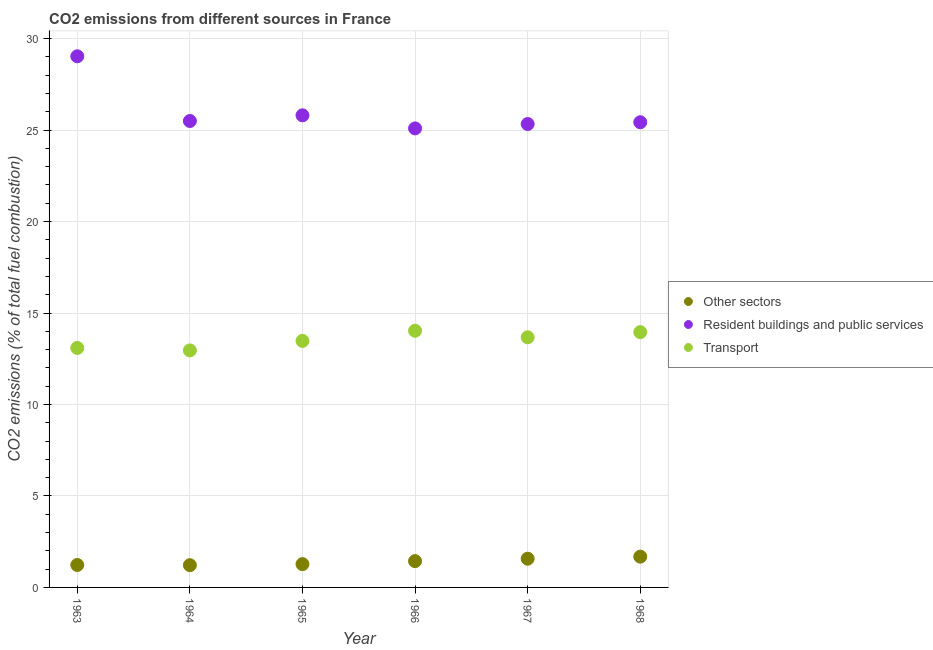How many different coloured dotlines are there?
Make the answer very short. 3. Is the number of dotlines equal to the number of legend labels?
Offer a very short reply. Yes. What is the percentage of co2 emissions from other sectors in 1968?
Your answer should be compact. 1.68. Across all years, what is the maximum percentage of co2 emissions from other sectors?
Offer a very short reply. 1.68. Across all years, what is the minimum percentage of co2 emissions from resident buildings and public services?
Offer a very short reply. 25.09. In which year was the percentage of co2 emissions from resident buildings and public services maximum?
Your answer should be very brief. 1963. In which year was the percentage of co2 emissions from transport minimum?
Your answer should be compact. 1964. What is the total percentage of co2 emissions from resident buildings and public services in the graph?
Ensure brevity in your answer.  156.19. What is the difference between the percentage of co2 emissions from resident buildings and public services in 1967 and that in 1968?
Your answer should be compact. -0.1. What is the difference between the percentage of co2 emissions from transport in 1966 and the percentage of co2 emissions from other sectors in 1965?
Your answer should be very brief. 12.76. What is the average percentage of co2 emissions from other sectors per year?
Keep it short and to the point. 1.4. In the year 1967, what is the difference between the percentage of co2 emissions from transport and percentage of co2 emissions from other sectors?
Your answer should be compact. 12.1. What is the ratio of the percentage of co2 emissions from other sectors in 1966 to that in 1968?
Your answer should be compact. 0.85. What is the difference between the highest and the second highest percentage of co2 emissions from transport?
Your response must be concise. 0.07. What is the difference between the highest and the lowest percentage of co2 emissions from resident buildings and public services?
Give a very brief answer. 3.94. In how many years, is the percentage of co2 emissions from other sectors greater than the average percentage of co2 emissions from other sectors taken over all years?
Ensure brevity in your answer.  3. Is it the case that in every year, the sum of the percentage of co2 emissions from other sectors and percentage of co2 emissions from resident buildings and public services is greater than the percentage of co2 emissions from transport?
Keep it short and to the point. Yes. Does the percentage of co2 emissions from other sectors monotonically increase over the years?
Your response must be concise. No. How many years are there in the graph?
Offer a very short reply. 6. What is the difference between two consecutive major ticks on the Y-axis?
Your response must be concise. 5. Are the values on the major ticks of Y-axis written in scientific E-notation?
Your answer should be compact. No. Does the graph contain any zero values?
Provide a succinct answer. No. Does the graph contain grids?
Make the answer very short. Yes. Where does the legend appear in the graph?
Ensure brevity in your answer.  Center right. How many legend labels are there?
Your response must be concise. 3. How are the legend labels stacked?
Ensure brevity in your answer.  Vertical. What is the title of the graph?
Offer a very short reply. CO2 emissions from different sources in France. What is the label or title of the Y-axis?
Your answer should be compact. CO2 emissions (% of total fuel combustion). What is the CO2 emissions (% of total fuel combustion) in Other sectors in 1963?
Your response must be concise. 1.23. What is the CO2 emissions (% of total fuel combustion) of Resident buildings and public services in 1963?
Provide a short and direct response. 29.04. What is the CO2 emissions (% of total fuel combustion) of Transport in 1963?
Your answer should be compact. 13.09. What is the CO2 emissions (% of total fuel combustion) of Other sectors in 1964?
Offer a very short reply. 1.22. What is the CO2 emissions (% of total fuel combustion) of Resident buildings and public services in 1964?
Make the answer very short. 25.5. What is the CO2 emissions (% of total fuel combustion) of Transport in 1964?
Your answer should be compact. 12.96. What is the CO2 emissions (% of total fuel combustion) of Other sectors in 1965?
Make the answer very short. 1.27. What is the CO2 emissions (% of total fuel combustion) of Resident buildings and public services in 1965?
Make the answer very short. 25.81. What is the CO2 emissions (% of total fuel combustion) in Transport in 1965?
Offer a terse response. 13.48. What is the CO2 emissions (% of total fuel combustion) in Other sectors in 1966?
Your response must be concise. 1.44. What is the CO2 emissions (% of total fuel combustion) in Resident buildings and public services in 1966?
Give a very brief answer. 25.09. What is the CO2 emissions (% of total fuel combustion) in Transport in 1966?
Offer a very short reply. 14.03. What is the CO2 emissions (% of total fuel combustion) in Other sectors in 1967?
Keep it short and to the point. 1.57. What is the CO2 emissions (% of total fuel combustion) of Resident buildings and public services in 1967?
Give a very brief answer. 25.33. What is the CO2 emissions (% of total fuel combustion) of Transport in 1967?
Provide a short and direct response. 13.67. What is the CO2 emissions (% of total fuel combustion) of Other sectors in 1968?
Your answer should be very brief. 1.68. What is the CO2 emissions (% of total fuel combustion) of Resident buildings and public services in 1968?
Offer a very short reply. 25.43. What is the CO2 emissions (% of total fuel combustion) of Transport in 1968?
Provide a short and direct response. 13.96. Across all years, what is the maximum CO2 emissions (% of total fuel combustion) in Other sectors?
Keep it short and to the point. 1.68. Across all years, what is the maximum CO2 emissions (% of total fuel combustion) in Resident buildings and public services?
Ensure brevity in your answer.  29.04. Across all years, what is the maximum CO2 emissions (% of total fuel combustion) of Transport?
Your answer should be compact. 14.03. Across all years, what is the minimum CO2 emissions (% of total fuel combustion) of Other sectors?
Your answer should be compact. 1.22. Across all years, what is the minimum CO2 emissions (% of total fuel combustion) of Resident buildings and public services?
Offer a very short reply. 25.09. Across all years, what is the minimum CO2 emissions (% of total fuel combustion) of Transport?
Ensure brevity in your answer.  12.96. What is the total CO2 emissions (% of total fuel combustion) of Other sectors in the graph?
Give a very brief answer. 8.41. What is the total CO2 emissions (% of total fuel combustion) of Resident buildings and public services in the graph?
Your answer should be compact. 156.19. What is the total CO2 emissions (% of total fuel combustion) in Transport in the graph?
Give a very brief answer. 81.18. What is the difference between the CO2 emissions (% of total fuel combustion) in Other sectors in 1963 and that in 1964?
Offer a very short reply. 0.01. What is the difference between the CO2 emissions (% of total fuel combustion) of Resident buildings and public services in 1963 and that in 1964?
Your response must be concise. 3.54. What is the difference between the CO2 emissions (% of total fuel combustion) of Transport in 1963 and that in 1964?
Offer a terse response. 0.14. What is the difference between the CO2 emissions (% of total fuel combustion) in Other sectors in 1963 and that in 1965?
Offer a very short reply. -0.05. What is the difference between the CO2 emissions (% of total fuel combustion) in Resident buildings and public services in 1963 and that in 1965?
Offer a very short reply. 3.23. What is the difference between the CO2 emissions (% of total fuel combustion) in Transport in 1963 and that in 1965?
Make the answer very short. -0.39. What is the difference between the CO2 emissions (% of total fuel combustion) of Other sectors in 1963 and that in 1966?
Make the answer very short. -0.21. What is the difference between the CO2 emissions (% of total fuel combustion) in Resident buildings and public services in 1963 and that in 1966?
Provide a succinct answer. 3.94. What is the difference between the CO2 emissions (% of total fuel combustion) of Transport in 1963 and that in 1966?
Your answer should be compact. -0.94. What is the difference between the CO2 emissions (% of total fuel combustion) of Other sectors in 1963 and that in 1967?
Ensure brevity in your answer.  -0.34. What is the difference between the CO2 emissions (% of total fuel combustion) of Resident buildings and public services in 1963 and that in 1967?
Give a very brief answer. 3.7. What is the difference between the CO2 emissions (% of total fuel combustion) in Transport in 1963 and that in 1967?
Keep it short and to the point. -0.58. What is the difference between the CO2 emissions (% of total fuel combustion) of Other sectors in 1963 and that in 1968?
Your answer should be very brief. -0.46. What is the difference between the CO2 emissions (% of total fuel combustion) in Resident buildings and public services in 1963 and that in 1968?
Give a very brief answer. 3.61. What is the difference between the CO2 emissions (% of total fuel combustion) of Transport in 1963 and that in 1968?
Your answer should be very brief. -0.87. What is the difference between the CO2 emissions (% of total fuel combustion) of Other sectors in 1964 and that in 1965?
Your answer should be very brief. -0.06. What is the difference between the CO2 emissions (% of total fuel combustion) of Resident buildings and public services in 1964 and that in 1965?
Your response must be concise. -0.31. What is the difference between the CO2 emissions (% of total fuel combustion) of Transport in 1964 and that in 1965?
Make the answer very short. -0.52. What is the difference between the CO2 emissions (% of total fuel combustion) in Other sectors in 1964 and that in 1966?
Offer a very short reply. -0.22. What is the difference between the CO2 emissions (% of total fuel combustion) in Resident buildings and public services in 1964 and that in 1966?
Ensure brevity in your answer.  0.4. What is the difference between the CO2 emissions (% of total fuel combustion) of Transport in 1964 and that in 1966?
Provide a succinct answer. -1.07. What is the difference between the CO2 emissions (% of total fuel combustion) in Other sectors in 1964 and that in 1967?
Give a very brief answer. -0.35. What is the difference between the CO2 emissions (% of total fuel combustion) of Resident buildings and public services in 1964 and that in 1967?
Provide a short and direct response. 0.17. What is the difference between the CO2 emissions (% of total fuel combustion) in Transport in 1964 and that in 1967?
Provide a succinct answer. -0.72. What is the difference between the CO2 emissions (% of total fuel combustion) in Other sectors in 1964 and that in 1968?
Give a very brief answer. -0.47. What is the difference between the CO2 emissions (% of total fuel combustion) of Resident buildings and public services in 1964 and that in 1968?
Provide a short and direct response. 0.07. What is the difference between the CO2 emissions (% of total fuel combustion) in Transport in 1964 and that in 1968?
Offer a very short reply. -1. What is the difference between the CO2 emissions (% of total fuel combustion) in Other sectors in 1965 and that in 1966?
Offer a terse response. -0.16. What is the difference between the CO2 emissions (% of total fuel combustion) in Resident buildings and public services in 1965 and that in 1966?
Ensure brevity in your answer.  0.71. What is the difference between the CO2 emissions (% of total fuel combustion) in Transport in 1965 and that in 1966?
Your answer should be very brief. -0.55. What is the difference between the CO2 emissions (% of total fuel combustion) in Other sectors in 1965 and that in 1967?
Make the answer very short. -0.3. What is the difference between the CO2 emissions (% of total fuel combustion) in Resident buildings and public services in 1965 and that in 1967?
Provide a short and direct response. 0.48. What is the difference between the CO2 emissions (% of total fuel combustion) of Transport in 1965 and that in 1967?
Offer a terse response. -0.2. What is the difference between the CO2 emissions (% of total fuel combustion) of Other sectors in 1965 and that in 1968?
Provide a short and direct response. -0.41. What is the difference between the CO2 emissions (% of total fuel combustion) of Resident buildings and public services in 1965 and that in 1968?
Offer a very short reply. 0.38. What is the difference between the CO2 emissions (% of total fuel combustion) of Transport in 1965 and that in 1968?
Offer a very short reply. -0.48. What is the difference between the CO2 emissions (% of total fuel combustion) of Other sectors in 1966 and that in 1967?
Your response must be concise. -0.13. What is the difference between the CO2 emissions (% of total fuel combustion) in Resident buildings and public services in 1966 and that in 1967?
Keep it short and to the point. -0.24. What is the difference between the CO2 emissions (% of total fuel combustion) of Transport in 1966 and that in 1967?
Your response must be concise. 0.36. What is the difference between the CO2 emissions (% of total fuel combustion) of Other sectors in 1966 and that in 1968?
Give a very brief answer. -0.24. What is the difference between the CO2 emissions (% of total fuel combustion) in Resident buildings and public services in 1966 and that in 1968?
Offer a very short reply. -0.34. What is the difference between the CO2 emissions (% of total fuel combustion) of Transport in 1966 and that in 1968?
Make the answer very short. 0.07. What is the difference between the CO2 emissions (% of total fuel combustion) of Other sectors in 1967 and that in 1968?
Keep it short and to the point. -0.11. What is the difference between the CO2 emissions (% of total fuel combustion) of Resident buildings and public services in 1967 and that in 1968?
Offer a terse response. -0.1. What is the difference between the CO2 emissions (% of total fuel combustion) of Transport in 1967 and that in 1968?
Provide a short and direct response. -0.28. What is the difference between the CO2 emissions (% of total fuel combustion) of Other sectors in 1963 and the CO2 emissions (% of total fuel combustion) of Resident buildings and public services in 1964?
Keep it short and to the point. -24.27. What is the difference between the CO2 emissions (% of total fuel combustion) of Other sectors in 1963 and the CO2 emissions (% of total fuel combustion) of Transport in 1964?
Make the answer very short. -11.73. What is the difference between the CO2 emissions (% of total fuel combustion) of Resident buildings and public services in 1963 and the CO2 emissions (% of total fuel combustion) of Transport in 1964?
Offer a very short reply. 16.08. What is the difference between the CO2 emissions (% of total fuel combustion) of Other sectors in 1963 and the CO2 emissions (% of total fuel combustion) of Resident buildings and public services in 1965?
Offer a terse response. -24.58. What is the difference between the CO2 emissions (% of total fuel combustion) of Other sectors in 1963 and the CO2 emissions (% of total fuel combustion) of Transport in 1965?
Your answer should be very brief. -12.25. What is the difference between the CO2 emissions (% of total fuel combustion) of Resident buildings and public services in 1963 and the CO2 emissions (% of total fuel combustion) of Transport in 1965?
Offer a very short reply. 15.56. What is the difference between the CO2 emissions (% of total fuel combustion) of Other sectors in 1963 and the CO2 emissions (% of total fuel combustion) of Resident buildings and public services in 1966?
Offer a terse response. -23.87. What is the difference between the CO2 emissions (% of total fuel combustion) of Other sectors in 1963 and the CO2 emissions (% of total fuel combustion) of Transport in 1966?
Offer a terse response. -12.8. What is the difference between the CO2 emissions (% of total fuel combustion) in Resident buildings and public services in 1963 and the CO2 emissions (% of total fuel combustion) in Transport in 1966?
Your response must be concise. 15. What is the difference between the CO2 emissions (% of total fuel combustion) of Other sectors in 1963 and the CO2 emissions (% of total fuel combustion) of Resident buildings and public services in 1967?
Provide a succinct answer. -24.1. What is the difference between the CO2 emissions (% of total fuel combustion) in Other sectors in 1963 and the CO2 emissions (% of total fuel combustion) in Transport in 1967?
Your response must be concise. -12.45. What is the difference between the CO2 emissions (% of total fuel combustion) in Resident buildings and public services in 1963 and the CO2 emissions (% of total fuel combustion) in Transport in 1967?
Make the answer very short. 15.36. What is the difference between the CO2 emissions (% of total fuel combustion) of Other sectors in 1963 and the CO2 emissions (% of total fuel combustion) of Resident buildings and public services in 1968?
Provide a succinct answer. -24.2. What is the difference between the CO2 emissions (% of total fuel combustion) of Other sectors in 1963 and the CO2 emissions (% of total fuel combustion) of Transport in 1968?
Provide a short and direct response. -12.73. What is the difference between the CO2 emissions (% of total fuel combustion) in Resident buildings and public services in 1963 and the CO2 emissions (% of total fuel combustion) in Transport in 1968?
Offer a terse response. 15.08. What is the difference between the CO2 emissions (% of total fuel combustion) of Other sectors in 1964 and the CO2 emissions (% of total fuel combustion) of Resident buildings and public services in 1965?
Your answer should be very brief. -24.59. What is the difference between the CO2 emissions (% of total fuel combustion) of Other sectors in 1964 and the CO2 emissions (% of total fuel combustion) of Transport in 1965?
Keep it short and to the point. -12.26. What is the difference between the CO2 emissions (% of total fuel combustion) in Resident buildings and public services in 1964 and the CO2 emissions (% of total fuel combustion) in Transport in 1965?
Keep it short and to the point. 12.02. What is the difference between the CO2 emissions (% of total fuel combustion) in Other sectors in 1964 and the CO2 emissions (% of total fuel combustion) in Resident buildings and public services in 1966?
Offer a terse response. -23.88. What is the difference between the CO2 emissions (% of total fuel combustion) in Other sectors in 1964 and the CO2 emissions (% of total fuel combustion) in Transport in 1966?
Your answer should be very brief. -12.82. What is the difference between the CO2 emissions (% of total fuel combustion) of Resident buildings and public services in 1964 and the CO2 emissions (% of total fuel combustion) of Transport in 1966?
Keep it short and to the point. 11.47. What is the difference between the CO2 emissions (% of total fuel combustion) in Other sectors in 1964 and the CO2 emissions (% of total fuel combustion) in Resident buildings and public services in 1967?
Keep it short and to the point. -24.12. What is the difference between the CO2 emissions (% of total fuel combustion) of Other sectors in 1964 and the CO2 emissions (% of total fuel combustion) of Transport in 1967?
Provide a short and direct response. -12.46. What is the difference between the CO2 emissions (% of total fuel combustion) of Resident buildings and public services in 1964 and the CO2 emissions (% of total fuel combustion) of Transport in 1967?
Ensure brevity in your answer.  11.82. What is the difference between the CO2 emissions (% of total fuel combustion) in Other sectors in 1964 and the CO2 emissions (% of total fuel combustion) in Resident buildings and public services in 1968?
Your answer should be very brief. -24.21. What is the difference between the CO2 emissions (% of total fuel combustion) of Other sectors in 1964 and the CO2 emissions (% of total fuel combustion) of Transport in 1968?
Your answer should be compact. -12.74. What is the difference between the CO2 emissions (% of total fuel combustion) in Resident buildings and public services in 1964 and the CO2 emissions (% of total fuel combustion) in Transport in 1968?
Keep it short and to the point. 11.54. What is the difference between the CO2 emissions (% of total fuel combustion) in Other sectors in 1965 and the CO2 emissions (% of total fuel combustion) in Resident buildings and public services in 1966?
Provide a succinct answer. -23.82. What is the difference between the CO2 emissions (% of total fuel combustion) in Other sectors in 1965 and the CO2 emissions (% of total fuel combustion) in Transport in 1966?
Offer a terse response. -12.76. What is the difference between the CO2 emissions (% of total fuel combustion) of Resident buildings and public services in 1965 and the CO2 emissions (% of total fuel combustion) of Transport in 1966?
Offer a very short reply. 11.78. What is the difference between the CO2 emissions (% of total fuel combustion) of Other sectors in 1965 and the CO2 emissions (% of total fuel combustion) of Resident buildings and public services in 1967?
Ensure brevity in your answer.  -24.06. What is the difference between the CO2 emissions (% of total fuel combustion) in Other sectors in 1965 and the CO2 emissions (% of total fuel combustion) in Transport in 1967?
Your answer should be very brief. -12.4. What is the difference between the CO2 emissions (% of total fuel combustion) in Resident buildings and public services in 1965 and the CO2 emissions (% of total fuel combustion) in Transport in 1967?
Provide a succinct answer. 12.14. What is the difference between the CO2 emissions (% of total fuel combustion) in Other sectors in 1965 and the CO2 emissions (% of total fuel combustion) in Resident buildings and public services in 1968?
Ensure brevity in your answer.  -24.15. What is the difference between the CO2 emissions (% of total fuel combustion) of Other sectors in 1965 and the CO2 emissions (% of total fuel combustion) of Transport in 1968?
Offer a terse response. -12.68. What is the difference between the CO2 emissions (% of total fuel combustion) of Resident buildings and public services in 1965 and the CO2 emissions (% of total fuel combustion) of Transport in 1968?
Provide a succinct answer. 11.85. What is the difference between the CO2 emissions (% of total fuel combustion) in Other sectors in 1966 and the CO2 emissions (% of total fuel combustion) in Resident buildings and public services in 1967?
Make the answer very short. -23.89. What is the difference between the CO2 emissions (% of total fuel combustion) of Other sectors in 1966 and the CO2 emissions (% of total fuel combustion) of Transport in 1967?
Offer a terse response. -12.23. What is the difference between the CO2 emissions (% of total fuel combustion) in Resident buildings and public services in 1966 and the CO2 emissions (% of total fuel combustion) in Transport in 1967?
Provide a succinct answer. 11.42. What is the difference between the CO2 emissions (% of total fuel combustion) of Other sectors in 1966 and the CO2 emissions (% of total fuel combustion) of Resident buildings and public services in 1968?
Your answer should be compact. -23.99. What is the difference between the CO2 emissions (% of total fuel combustion) in Other sectors in 1966 and the CO2 emissions (% of total fuel combustion) in Transport in 1968?
Offer a very short reply. -12.52. What is the difference between the CO2 emissions (% of total fuel combustion) of Resident buildings and public services in 1966 and the CO2 emissions (% of total fuel combustion) of Transport in 1968?
Provide a short and direct response. 11.14. What is the difference between the CO2 emissions (% of total fuel combustion) of Other sectors in 1967 and the CO2 emissions (% of total fuel combustion) of Resident buildings and public services in 1968?
Your answer should be compact. -23.86. What is the difference between the CO2 emissions (% of total fuel combustion) of Other sectors in 1967 and the CO2 emissions (% of total fuel combustion) of Transport in 1968?
Your answer should be compact. -12.39. What is the difference between the CO2 emissions (% of total fuel combustion) of Resident buildings and public services in 1967 and the CO2 emissions (% of total fuel combustion) of Transport in 1968?
Your response must be concise. 11.38. What is the average CO2 emissions (% of total fuel combustion) in Other sectors per year?
Offer a terse response. 1.4. What is the average CO2 emissions (% of total fuel combustion) of Resident buildings and public services per year?
Make the answer very short. 26.03. What is the average CO2 emissions (% of total fuel combustion) of Transport per year?
Make the answer very short. 13.53. In the year 1963, what is the difference between the CO2 emissions (% of total fuel combustion) of Other sectors and CO2 emissions (% of total fuel combustion) of Resident buildings and public services?
Your answer should be compact. -27.81. In the year 1963, what is the difference between the CO2 emissions (% of total fuel combustion) in Other sectors and CO2 emissions (% of total fuel combustion) in Transport?
Provide a short and direct response. -11.86. In the year 1963, what is the difference between the CO2 emissions (% of total fuel combustion) of Resident buildings and public services and CO2 emissions (% of total fuel combustion) of Transport?
Provide a short and direct response. 15.94. In the year 1964, what is the difference between the CO2 emissions (% of total fuel combustion) in Other sectors and CO2 emissions (% of total fuel combustion) in Resident buildings and public services?
Your response must be concise. -24.28. In the year 1964, what is the difference between the CO2 emissions (% of total fuel combustion) of Other sectors and CO2 emissions (% of total fuel combustion) of Transport?
Your response must be concise. -11.74. In the year 1964, what is the difference between the CO2 emissions (% of total fuel combustion) of Resident buildings and public services and CO2 emissions (% of total fuel combustion) of Transport?
Give a very brief answer. 12.54. In the year 1965, what is the difference between the CO2 emissions (% of total fuel combustion) of Other sectors and CO2 emissions (% of total fuel combustion) of Resident buildings and public services?
Ensure brevity in your answer.  -24.53. In the year 1965, what is the difference between the CO2 emissions (% of total fuel combustion) in Other sectors and CO2 emissions (% of total fuel combustion) in Transport?
Ensure brevity in your answer.  -12.2. In the year 1965, what is the difference between the CO2 emissions (% of total fuel combustion) of Resident buildings and public services and CO2 emissions (% of total fuel combustion) of Transport?
Your answer should be very brief. 12.33. In the year 1966, what is the difference between the CO2 emissions (% of total fuel combustion) in Other sectors and CO2 emissions (% of total fuel combustion) in Resident buildings and public services?
Provide a short and direct response. -23.65. In the year 1966, what is the difference between the CO2 emissions (% of total fuel combustion) of Other sectors and CO2 emissions (% of total fuel combustion) of Transport?
Your response must be concise. -12.59. In the year 1966, what is the difference between the CO2 emissions (% of total fuel combustion) of Resident buildings and public services and CO2 emissions (% of total fuel combustion) of Transport?
Your response must be concise. 11.06. In the year 1967, what is the difference between the CO2 emissions (% of total fuel combustion) in Other sectors and CO2 emissions (% of total fuel combustion) in Resident buildings and public services?
Provide a short and direct response. -23.76. In the year 1967, what is the difference between the CO2 emissions (% of total fuel combustion) in Other sectors and CO2 emissions (% of total fuel combustion) in Transport?
Ensure brevity in your answer.  -12.1. In the year 1967, what is the difference between the CO2 emissions (% of total fuel combustion) in Resident buildings and public services and CO2 emissions (% of total fuel combustion) in Transport?
Your answer should be compact. 11.66. In the year 1968, what is the difference between the CO2 emissions (% of total fuel combustion) in Other sectors and CO2 emissions (% of total fuel combustion) in Resident buildings and public services?
Give a very brief answer. -23.75. In the year 1968, what is the difference between the CO2 emissions (% of total fuel combustion) in Other sectors and CO2 emissions (% of total fuel combustion) in Transport?
Give a very brief answer. -12.27. In the year 1968, what is the difference between the CO2 emissions (% of total fuel combustion) in Resident buildings and public services and CO2 emissions (% of total fuel combustion) in Transport?
Your answer should be very brief. 11.47. What is the ratio of the CO2 emissions (% of total fuel combustion) of Other sectors in 1963 to that in 1964?
Make the answer very short. 1.01. What is the ratio of the CO2 emissions (% of total fuel combustion) of Resident buildings and public services in 1963 to that in 1964?
Your response must be concise. 1.14. What is the ratio of the CO2 emissions (% of total fuel combustion) in Transport in 1963 to that in 1964?
Your response must be concise. 1.01. What is the ratio of the CO2 emissions (% of total fuel combustion) in Other sectors in 1963 to that in 1965?
Your response must be concise. 0.96. What is the ratio of the CO2 emissions (% of total fuel combustion) of Resident buildings and public services in 1963 to that in 1965?
Your answer should be compact. 1.13. What is the ratio of the CO2 emissions (% of total fuel combustion) in Transport in 1963 to that in 1965?
Offer a very short reply. 0.97. What is the ratio of the CO2 emissions (% of total fuel combustion) in Other sectors in 1963 to that in 1966?
Provide a short and direct response. 0.85. What is the ratio of the CO2 emissions (% of total fuel combustion) in Resident buildings and public services in 1963 to that in 1966?
Make the answer very short. 1.16. What is the ratio of the CO2 emissions (% of total fuel combustion) of Transport in 1963 to that in 1966?
Make the answer very short. 0.93. What is the ratio of the CO2 emissions (% of total fuel combustion) of Other sectors in 1963 to that in 1967?
Offer a terse response. 0.78. What is the ratio of the CO2 emissions (% of total fuel combustion) in Resident buildings and public services in 1963 to that in 1967?
Make the answer very short. 1.15. What is the ratio of the CO2 emissions (% of total fuel combustion) of Transport in 1963 to that in 1967?
Offer a very short reply. 0.96. What is the ratio of the CO2 emissions (% of total fuel combustion) in Other sectors in 1963 to that in 1968?
Your answer should be compact. 0.73. What is the ratio of the CO2 emissions (% of total fuel combustion) of Resident buildings and public services in 1963 to that in 1968?
Ensure brevity in your answer.  1.14. What is the ratio of the CO2 emissions (% of total fuel combustion) in Transport in 1963 to that in 1968?
Make the answer very short. 0.94. What is the ratio of the CO2 emissions (% of total fuel combustion) of Other sectors in 1964 to that in 1965?
Your answer should be compact. 0.95. What is the ratio of the CO2 emissions (% of total fuel combustion) in Transport in 1964 to that in 1965?
Keep it short and to the point. 0.96. What is the ratio of the CO2 emissions (% of total fuel combustion) of Other sectors in 1964 to that in 1966?
Offer a terse response. 0.85. What is the ratio of the CO2 emissions (% of total fuel combustion) of Resident buildings and public services in 1964 to that in 1966?
Give a very brief answer. 1.02. What is the ratio of the CO2 emissions (% of total fuel combustion) in Transport in 1964 to that in 1966?
Provide a short and direct response. 0.92. What is the ratio of the CO2 emissions (% of total fuel combustion) in Other sectors in 1964 to that in 1967?
Ensure brevity in your answer.  0.77. What is the ratio of the CO2 emissions (% of total fuel combustion) of Resident buildings and public services in 1964 to that in 1967?
Keep it short and to the point. 1.01. What is the ratio of the CO2 emissions (% of total fuel combustion) of Transport in 1964 to that in 1967?
Your response must be concise. 0.95. What is the ratio of the CO2 emissions (% of total fuel combustion) in Other sectors in 1964 to that in 1968?
Your answer should be very brief. 0.72. What is the ratio of the CO2 emissions (% of total fuel combustion) in Resident buildings and public services in 1964 to that in 1968?
Your answer should be compact. 1. What is the ratio of the CO2 emissions (% of total fuel combustion) in Transport in 1964 to that in 1968?
Give a very brief answer. 0.93. What is the ratio of the CO2 emissions (% of total fuel combustion) of Other sectors in 1965 to that in 1966?
Make the answer very short. 0.89. What is the ratio of the CO2 emissions (% of total fuel combustion) of Resident buildings and public services in 1965 to that in 1966?
Keep it short and to the point. 1.03. What is the ratio of the CO2 emissions (% of total fuel combustion) of Transport in 1965 to that in 1966?
Give a very brief answer. 0.96. What is the ratio of the CO2 emissions (% of total fuel combustion) in Other sectors in 1965 to that in 1967?
Offer a terse response. 0.81. What is the ratio of the CO2 emissions (% of total fuel combustion) of Resident buildings and public services in 1965 to that in 1967?
Give a very brief answer. 1.02. What is the ratio of the CO2 emissions (% of total fuel combustion) in Transport in 1965 to that in 1967?
Ensure brevity in your answer.  0.99. What is the ratio of the CO2 emissions (% of total fuel combustion) of Other sectors in 1965 to that in 1968?
Give a very brief answer. 0.76. What is the ratio of the CO2 emissions (% of total fuel combustion) in Resident buildings and public services in 1965 to that in 1968?
Ensure brevity in your answer.  1.01. What is the ratio of the CO2 emissions (% of total fuel combustion) of Transport in 1965 to that in 1968?
Provide a succinct answer. 0.97. What is the ratio of the CO2 emissions (% of total fuel combustion) of Other sectors in 1966 to that in 1967?
Keep it short and to the point. 0.92. What is the ratio of the CO2 emissions (% of total fuel combustion) of Resident buildings and public services in 1966 to that in 1967?
Your response must be concise. 0.99. What is the ratio of the CO2 emissions (% of total fuel combustion) in Transport in 1966 to that in 1967?
Offer a very short reply. 1.03. What is the ratio of the CO2 emissions (% of total fuel combustion) of Other sectors in 1966 to that in 1968?
Ensure brevity in your answer.  0.85. What is the ratio of the CO2 emissions (% of total fuel combustion) of Resident buildings and public services in 1966 to that in 1968?
Provide a succinct answer. 0.99. What is the ratio of the CO2 emissions (% of total fuel combustion) of Transport in 1966 to that in 1968?
Provide a succinct answer. 1.01. What is the ratio of the CO2 emissions (% of total fuel combustion) of Other sectors in 1967 to that in 1968?
Your answer should be compact. 0.93. What is the ratio of the CO2 emissions (% of total fuel combustion) in Resident buildings and public services in 1967 to that in 1968?
Provide a succinct answer. 1. What is the ratio of the CO2 emissions (% of total fuel combustion) of Transport in 1967 to that in 1968?
Provide a short and direct response. 0.98. What is the difference between the highest and the second highest CO2 emissions (% of total fuel combustion) of Other sectors?
Provide a short and direct response. 0.11. What is the difference between the highest and the second highest CO2 emissions (% of total fuel combustion) of Resident buildings and public services?
Your answer should be compact. 3.23. What is the difference between the highest and the second highest CO2 emissions (% of total fuel combustion) in Transport?
Ensure brevity in your answer.  0.07. What is the difference between the highest and the lowest CO2 emissions (% of total fuel combustion) in Other sectors?
Give a very brief answer. 0.47. What is the difference between the highest and the lowest CO2 emissions (% of total fuel combustion) in Resident buildings and public services?
Make the answer very short. 3.94. What is the difference between the highest and the lowest CO2 emissions (% of total fuel combustion) in Transport?
Keep it short and to the point. 1.07. 